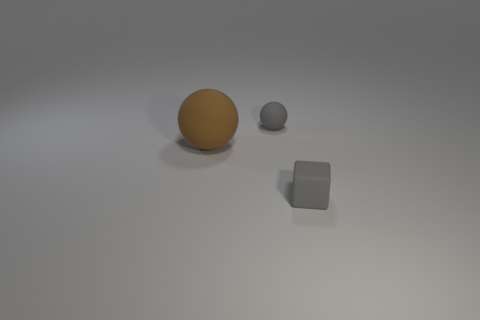How many other objects are there of the same size as the gray matte sphere? In the image, there is one object which is approximately the same size as the gray matte sphere; it's the cube with a matte surface. 